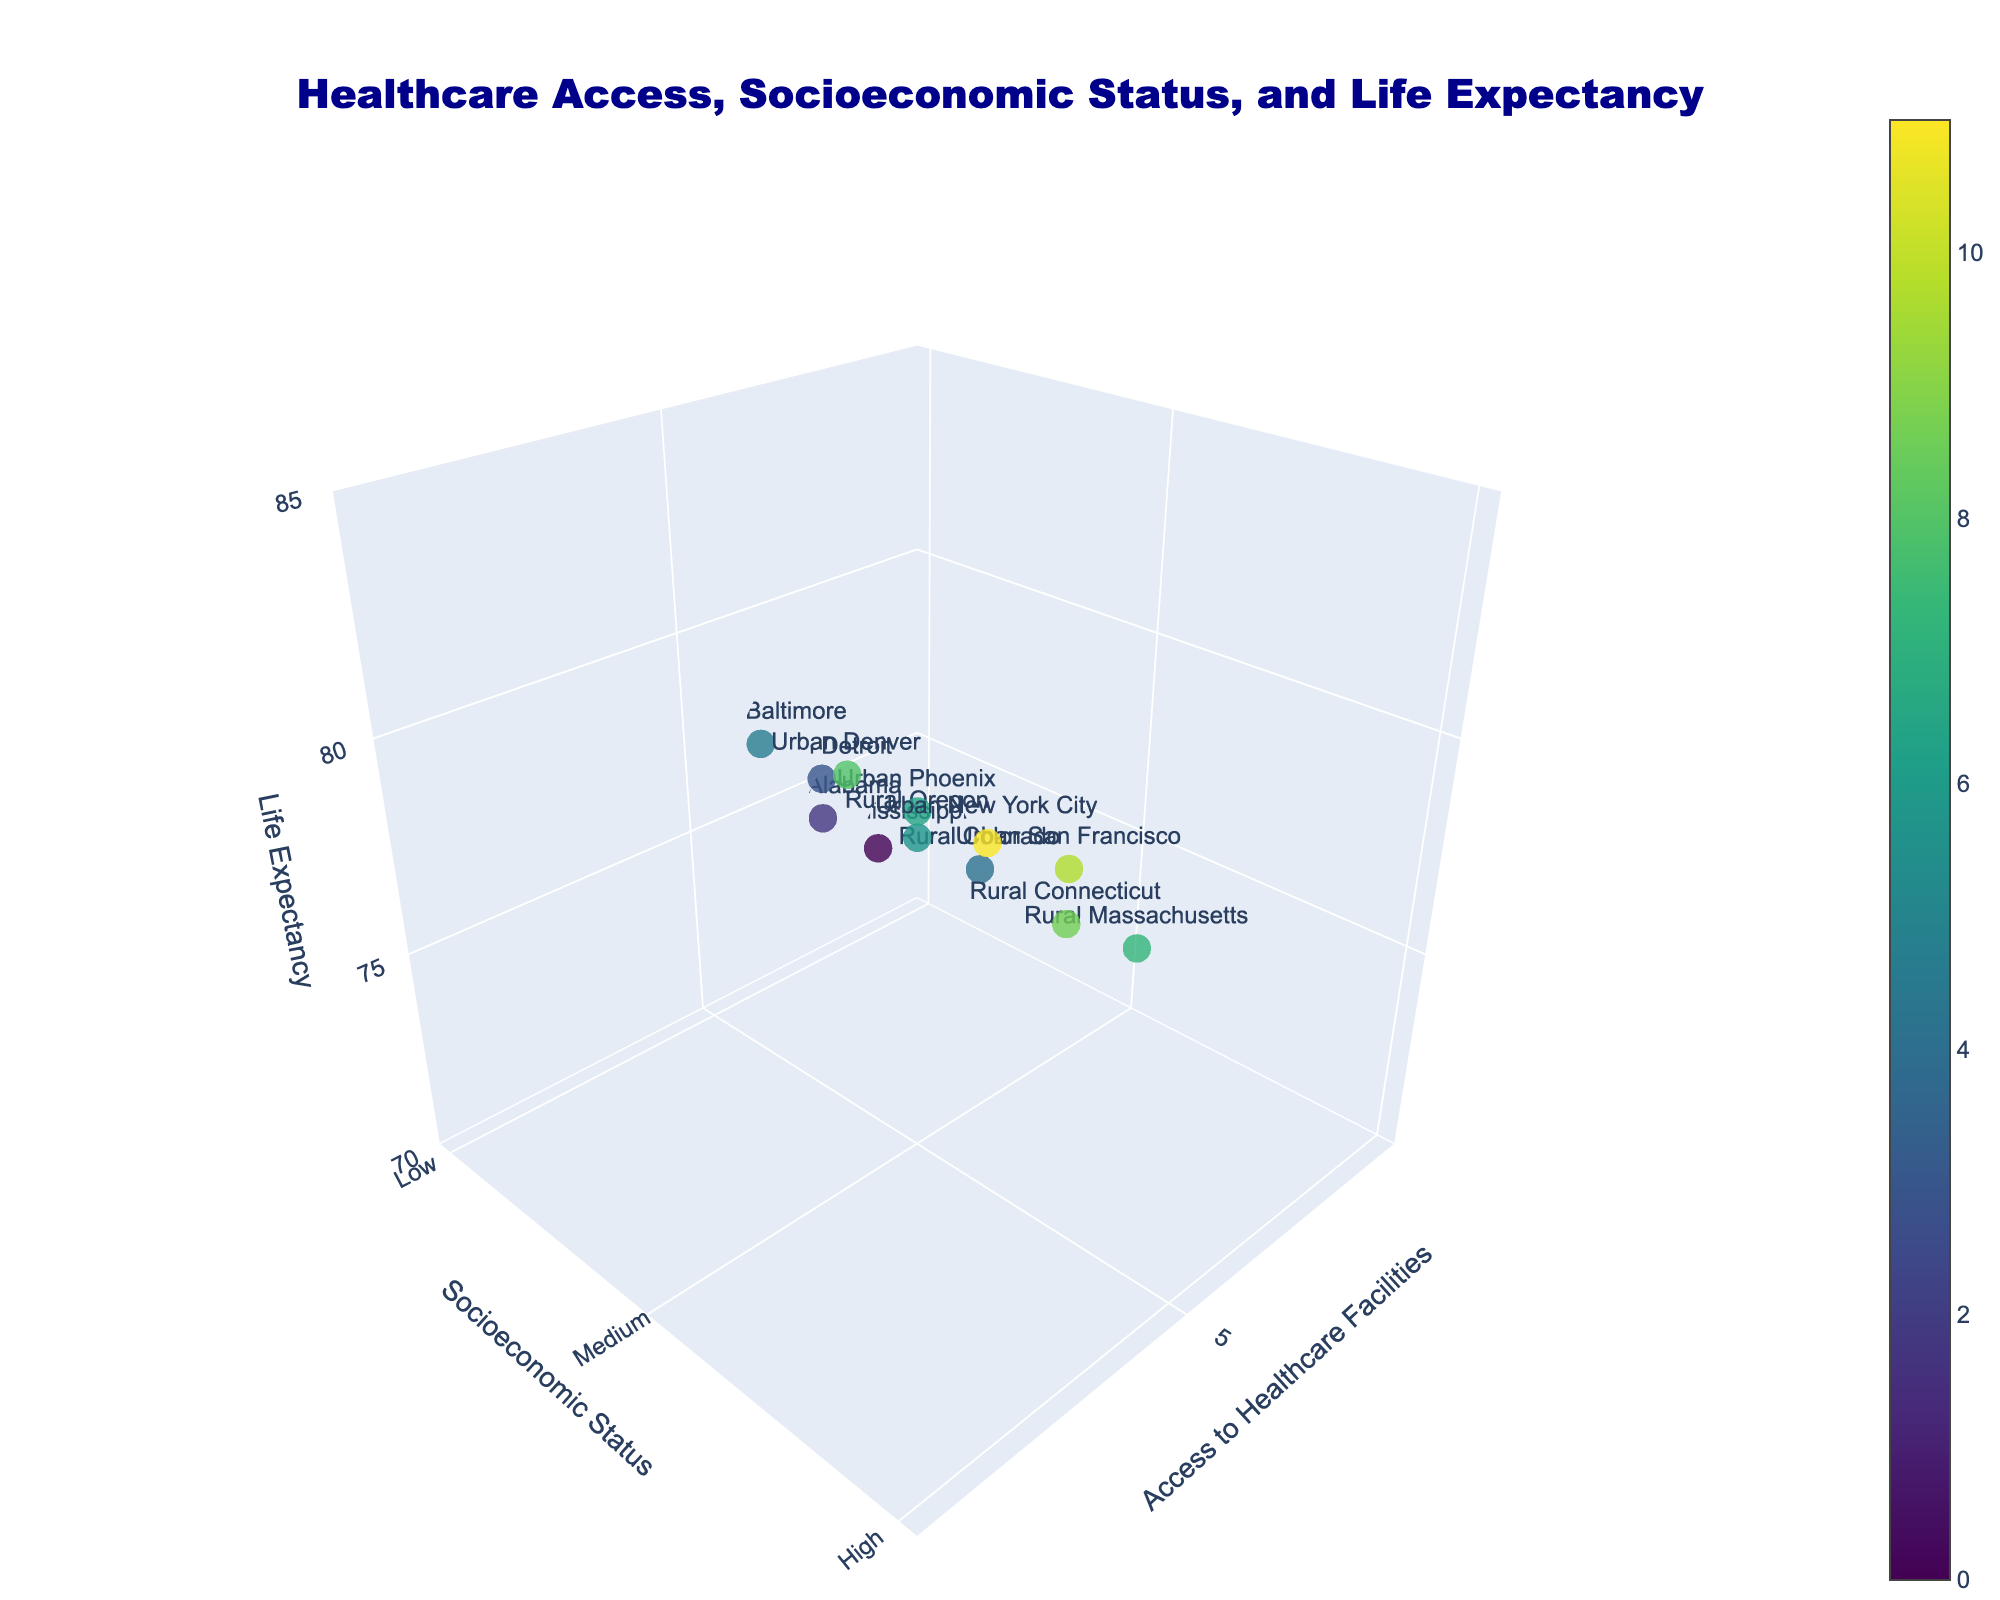How many rural areas are represented in the plot? The rural areas can be identified by the labels and can be counted. The rural areas are Mississippi, Alabama, Colorado, Oregon, Massachusetts, and Connecticut.
Answer: 6 In the plot, which region has the highest life expectancy? The region with the highest life expectancy is shown by the highest point on the z-axis. The highest life expectancy is 82.7, which corresponds to Urban New York City.
Answer: Urban New York City What is the relationship between access to healthcare facilities and socioeconomic status for regions with high life expectancy? High life expectancy regions (those above 80) can be identified on the z-axis. Then, we observe their respective x-axis (healthcare access) and y-axis (Socioeconomic status). These regions are Urban San Francisco and Urban New York City, both having high access to healthcare (7 and 8) and high socioeconomic status (mapped value 3).
Answer: They both have high access to healthcare and high socioeconomic status Which region has the lowest life expectancy, and what is its access to healthcare facilities and socioeconomic status? The lowest life expectancy can be found at the bottom of the z-axis. The corresponding data point is Rural Mississippi with 72.5 life expectancy, an access to healthcare value of 2, and low socioeconomic status.
Answer: Rural Mississippi, access: 2, SES: Low For regions with medium socioeconomic status, what is the range of life expectancies? Medium socioeconomic status corresponds to a y-axis value of 2 (Medium). The life expectancies for these regions (Rural Colorado, Rural Oregon, Urban Phoenix, Urban Denver) range from 76.3 to 79.9.
Answer: 76.3 to 79.9 How do rural and urban areas with low socioeconomic status compare in terms of life expectancy? Identify rural and urban regions with low socioeconomic status on y-axis value 1. Rural examples are Mississippi and Alabama with life expectancies 72.5 and 74.1 respectively. Urban examples are Detroit and Baltimore with life expectancies 75.2 and 76.8 respectively. Urban regions have higher life expectancies compared to rural in low socioeconomic status.
Answer: Urban areas have higher life expectancies than rural areas Is there a noticeable trend in life expectancy with increasing access to healthcare facilities for any particular socioeconomic status? Analyze how life expectancy changes along the z-axis as access to healthcare increases along the x-axis for each socioeconomic status (low, medium, high). For instance, for high SES (y=3), life expectancy increases from 79.2 to 82.7 as access increases from 6 to 8. Incremental increases in healthcare facilities improve life expectancy.
Answer: Yes, it generally increases What regions show a life expectancy between 75 and 80 years? Regions in the life expectancy range of 75 to 80 can be identified by checking points on the z-axis within this range. The regions are Rural Alabama, Rural Colorado, Rural Oregon, Urban Detroit, Urban Baltimore, and Urban Phoenix.
Answer: Rural Alabama, Rural Colorado, Rural Oregon, Urban Detroit, Urban Baltimore, Urban Phoenix 